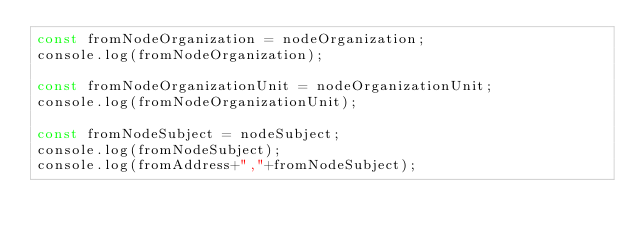<code> <loc_0><loc_0><loc_500><loc_500><_JavaScript_>const fromNodeOrganization = nodeOrganization;
console.log(fromNodeOrganization);

const fromNodeOrganizationUnit = nodeOrganizationUnit;
console.log(fromNodeOrganizationUnit);

const fromNodeSubject = nodeSubject;
console.log(fromNodeSubject);
console.log(fromAddress+","+fromNodeSubject);
</code> 